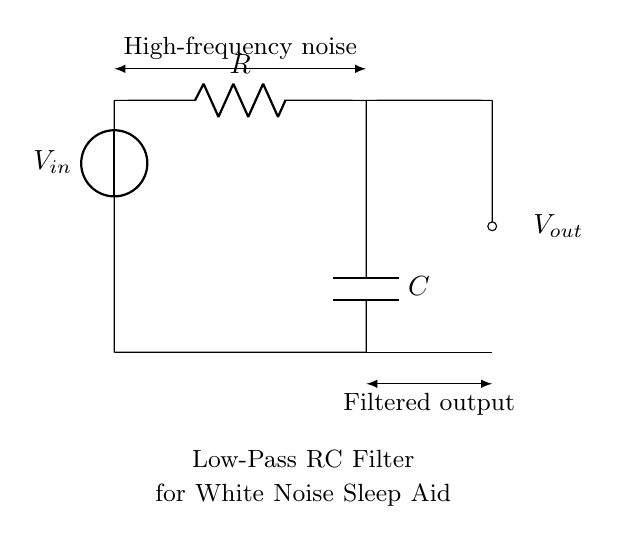What are the components in the circuit? The circuit contains a voltage source, a resistor, and a capacitor, as indicated by the symbols in the diagram.
Answer: Voltage source, resistor, capacitor What is the role of the resistor in this circuit? The resistor's primary function is to limit the current flowing through the circuit and to create a voltage drop, which influences the time constant of the RC filter.
Answer: Limit current What is the function of the capacitor in this circuit? The capacitor charges and discharges, allowing it to smooth out fluctuations in the signal, thus acting as a filter for high-frequency noise.
Answer: Smooth fluctuations What type of filter is represented in this circuit? The circuit represents a low-pass filter which allows low-frequency signals to pass while attenuating high-frequency signals.
Answer: Low-pass filter What is the expected output voltage behavior at high frequencies? At high frequencies, the output voltage will decrease significantly as the filter attenuates those signals, resulting in minimal output.
Answer: Minimal output How do resistor and capacitor values affect the filter's cutoff frequency? The cutoff frequency is determined by the values of the resistor and capacitor, specifically calculated as one over the product of R and C. Higher values of R or C lower the cutoff frequency.
Answer: Higher values lower cutoff frequency 